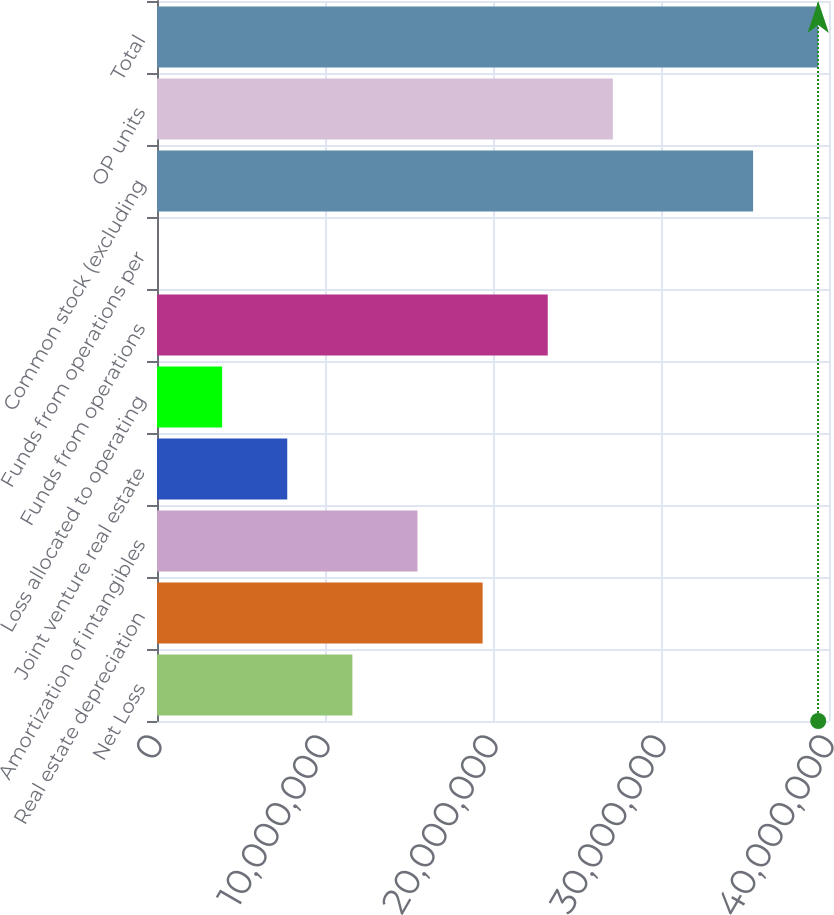Convert chart. <chart><loc_0><loc_0><loc_500><loc_500><bar_chart><fcel>Net Loss<fcel>Real estate depreciation<fcel>Amortization of intangibles<fcel>Joint venture real estate<fcel>Loss allocated to operating<fcel>Funds from operations<fcel>Funds from operations per<fcel>Common stock (excluding<fcel>OP units<fcel>Total<nl><fcel>1.16294e+07<fcel>1.93823e+07<fcel>1.55058e+07<fcel>7.75292e+06<fcel>3.87646e+06<fcel>2.32588e+07<fcel>0.7<fcel>3.54815e+07<fcel>2.71352e+07<fcel>3.9358e+07<nl></chart> 